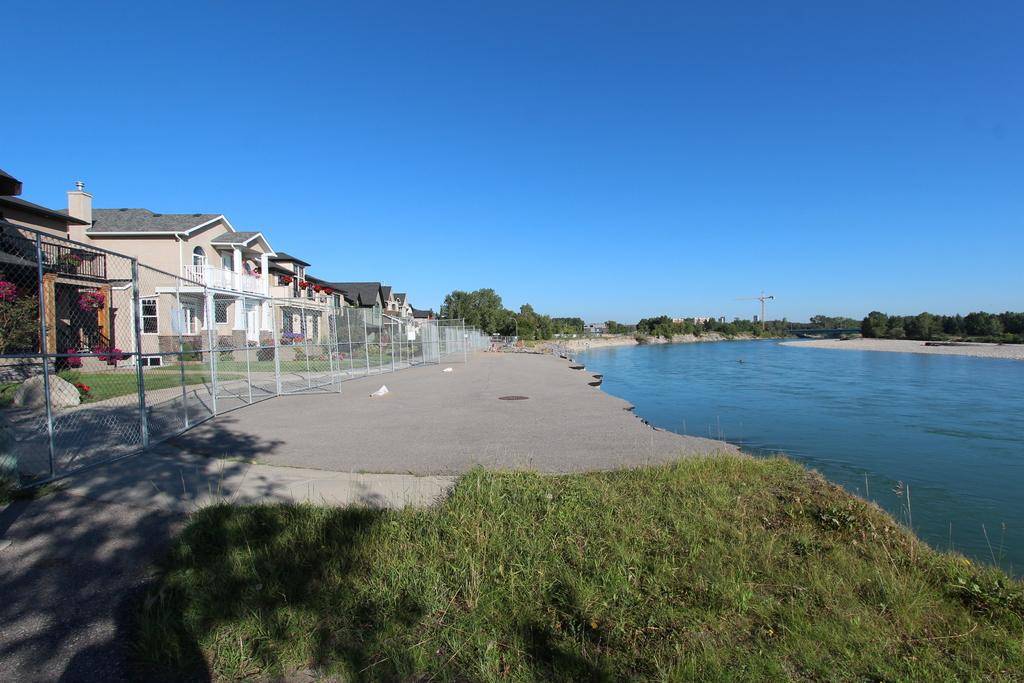What type of structure is present in the image? There is a shed house in the image. What can be seen surrounding the shed house? There is a white color net fencing grill in the image. What natural feature is on the left side of the image? There is a small lake with water on the left side of the image. What can be seen in the distance in the image? There are many trees visible in the background of the image. What type of crack is visible on the shed house in the image? There is no crack visible on the shed house in the image. What type of war is depicted in the image? There is no war depicted in the image; it features a shed house, a white color net fencing grill, a small lake, and many trees in the background. 